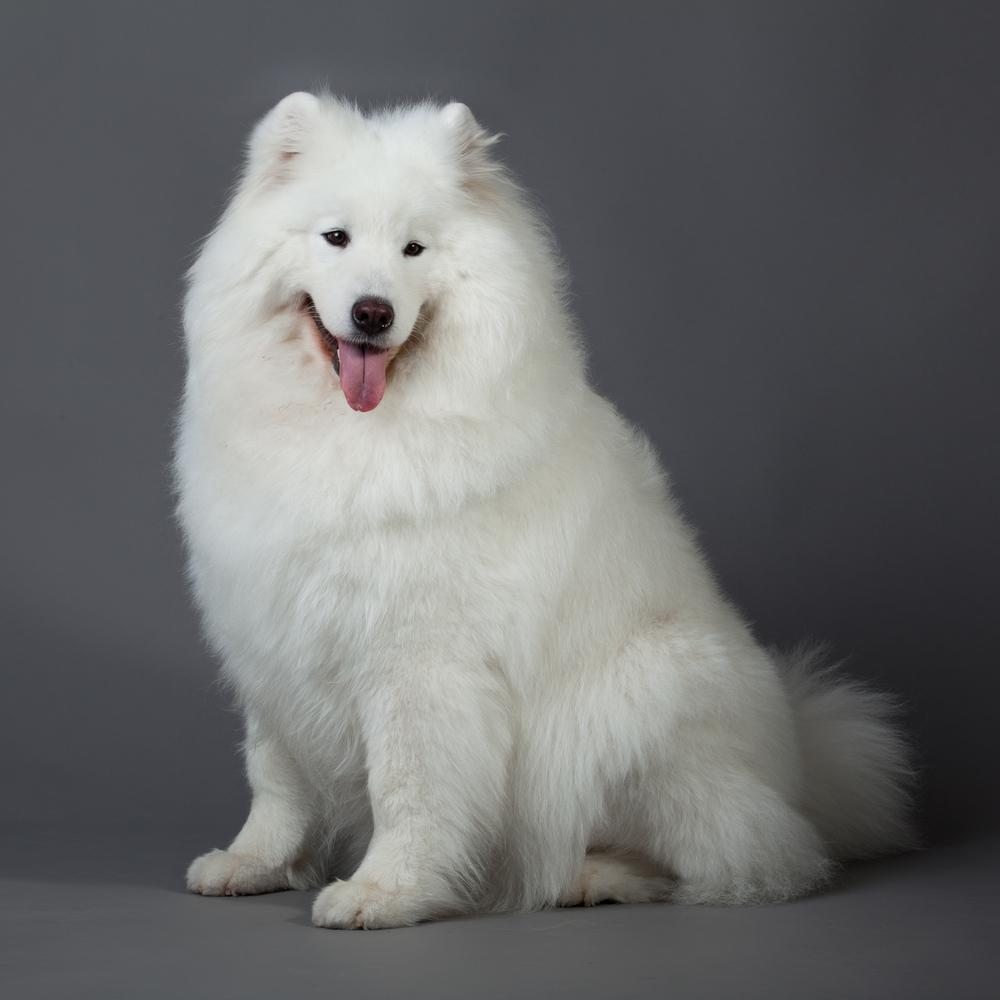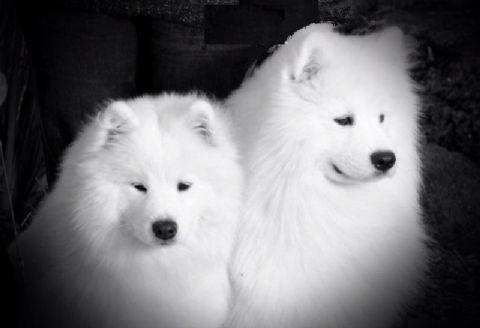The first image is the image on the left, the second image is the image on the right. Evaluate the accuracy of this statement regarding the images: "One of the images features two dogs side by side.". Is it true? Answer yes or no. Yes. The first image is the image on the left, the second image is the image on the right. For the images shown, is this caption "Only white dogs are shown and no image contains more than one dog, and one image shows a white non-standing dog with front paws forward." true? Answer yes or no. No. 